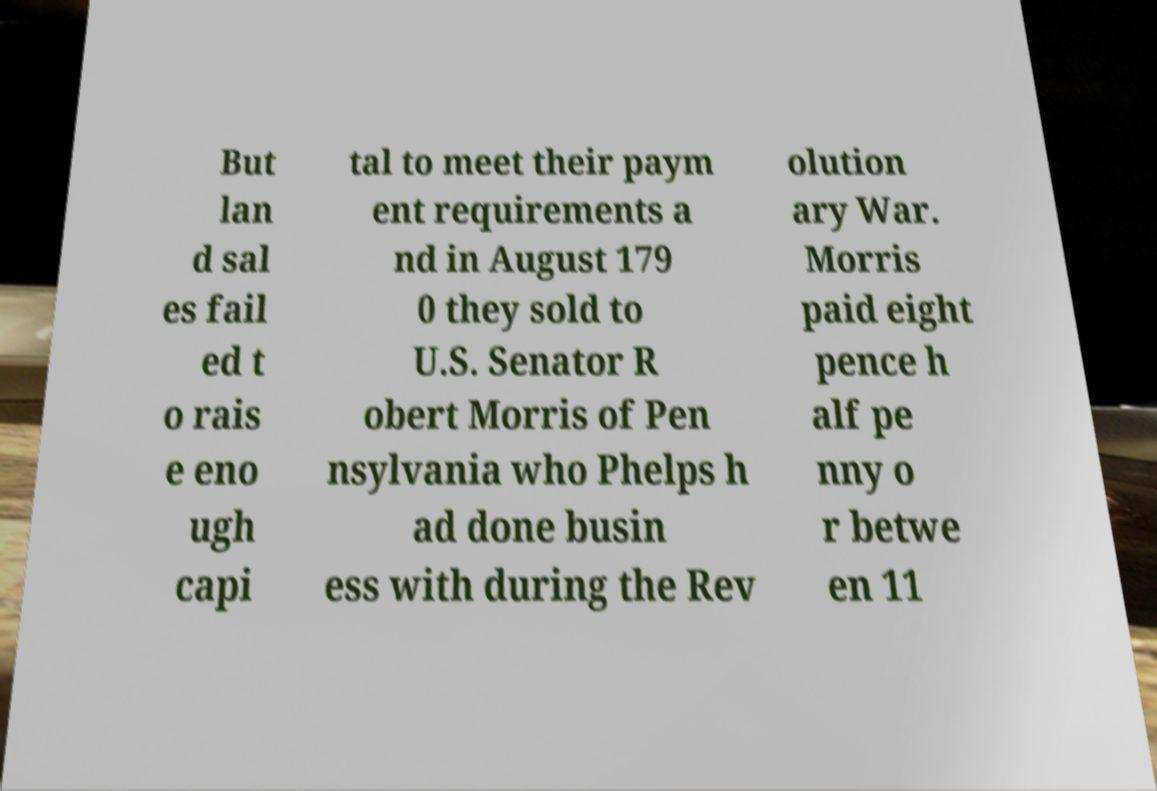Can you accurately transcribe the text from the provided image for me? But lan d sal es fail ed t o rais e eno ugh capi tal to meet their paym ent requirements a nd in August 179 0 they sold to U.S. Senator R obert Morris of Pen nsylvania who Phelps h ad done busin ess with during the Rev olution ary War. Morris paid eight pence h alf pe nny o r betwe en 11 